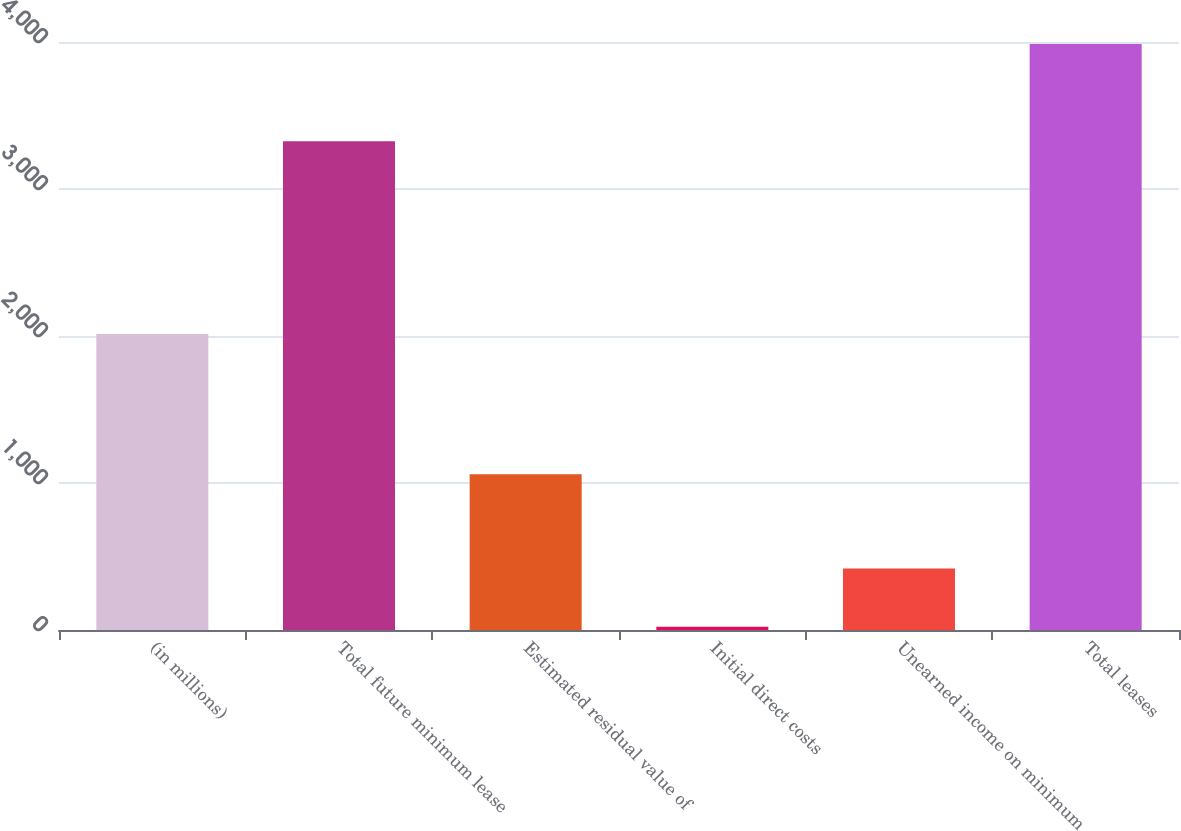Convert chart. <chart><loc_0><loc_0><loc_500><loc_500><bar_chart><fcel>(in millions)<fcel>Total future minimum lease<fcel>Estimated residual value of<fcel>Initial direct costs<fcel>Unearned income on minimum<fcel>Total leases<nl><fcel>2014<fcel>3324<fcel>1059<fcel>22<fcel>419<fcel>3986<nl></chart> 